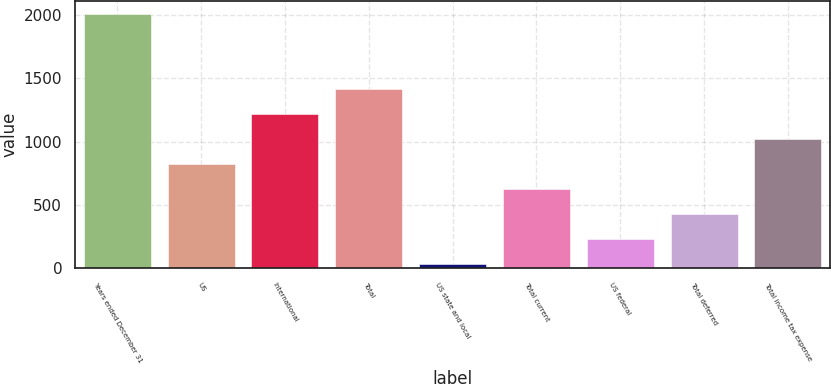Convert chart to OTSL. <chart><loc_0><loc_0><loc_500><loc_500><bar_chart><fcel>Years ended December 31<fcel>US<fcel>International<fcel>Total<fcel>US state and local<fcel>Total current<fcel>US federal<fcel>Total deferred<fcel>Total income tax expense<nl><fcel>2011<fcel>825.4<fcel>1220.6<fcel>1418.2<fcel>35<fcel>627.8<fcel>232.6<fcel>430.2<fcel>1023<nl></chart> 